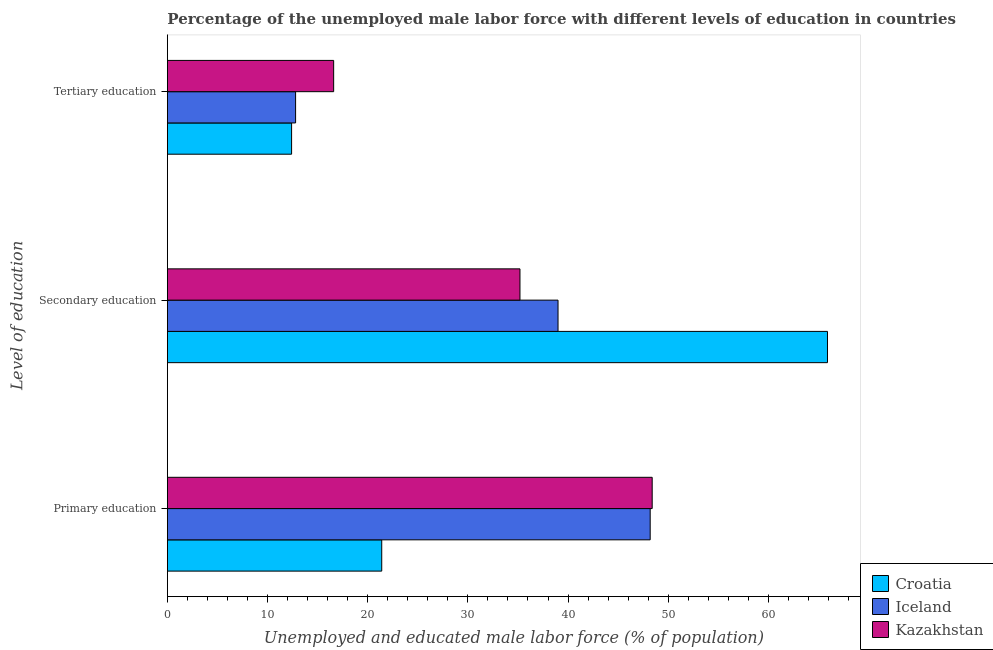How many different coloured bars are there?
Offer a terse response. 3. How many bars are there on the 2nd tick from the top?
Your response must be concise. 3. What is the label of the 2nd group of bars from the top?
Your answer should be compact. Secondary education. What is the percentage of male labor force who received secondary education in Croatia?
Provide a succinct answer. 65.9. Across all countries, what is the maximum percentage of male labor force who received tertiary education?
Make the answer very short. 16.6. Across all countries, what is the minimum percentage of male labor force who received secondary education?
Give a very brief answer. 35.2. In which country was the percentage of male labor force who received primary education maximum?
Your response must be concise. Kazakhstan. In which country was the percentage of male labor force who received tertiary education minimum?
Keep it short and to the point. Croatia. What is the total percentage of male labor force who received secondary education in the graph?
Offer a terse response. 140.1. What is the difference between the percentage of male labor force who received secondary education in Croatia and that in Kazakhstan?
Your response must be concise. 30.7. What is the difference between the percentage of male labor force who received primary education in Croatia and the percentage of male labor force who received tertiary education in Kazakhstan?
Keep it short and to the point. 4.8. What is the average percentage of male labor force who received tertiary education per country?
Provide a succinct answer. 13.93. What is the difference between the percentage of male labor force who received secondary education and percentage of male labor force who received tertiary education in Iceland?
Give a very brief answer. 26.2. What is the ratio of the percentage of male labor force who received tertiary education in Iceland to that in Croatia?
Offer a terse response. 1.03. Is the percentage of male labor force who received primary education in Croatia less than that in Kazakhstan?
Your answer should be compact. Yes. Is the difference between the percentage of male labor force who received secondary education in Croatia and Iceland greater than the difference between the percentage of male labor force who received tertiary education in Croatia and Iceland?
Your response must be concise. Yes. What is the difference between the highest and the second highest percentage of male labor force who received secondary education?
Ensure brevity in your answer.  26.9. What is the difference between the highest and the lowest percentage of male labor force who received primary education?
Your answer should be very brief. 27. In how many countries, is the percentage of male labor force who received primary education greater than the average percentage of male labor force who received primary education taken over all countries?
Ensure brevity in your answer.  2. Is the sum of the percentage of male labor force who received primary education in Iceland and Kazakhstan greater than the maximum percentage of male labor force who received tertiary education across all countries?
Make the answer very short. Yes. What does the 2nd bar from the top in Tertiary education represents?
Offer a very short reply. Iceland. What does the 3rd bar from the bottom in Tertiary education represents?
Give a very brief answer. Kazakhstan. Is it the case that in every country, the sum of the percentage of male labor force who received primary education and percentage of male labor force who received secondary education is greater than the percentage of male labor force who received tertiary education?
Give a very brief answer. Yes. How many bars are there?
Keep it short and to the point. 9. What is the difference between two consecutive major ticks on the X-axis?
Keep it short and to the point. 10. Does the graph contain grids?
Provide a short and direct response. No. How many legend labels are there?
Provide a succinct answer. 3. How are the legend labels stacked?
Provide a short and direct response. Vertical. What is the title of the graph?
Make the answer very short. Percentage of the unemployed male labor force with different levels of education in countries. Does "Sub-Saharan Africa (all income levels)" appear as one of the legend labels in the graph?
Keep it short and to the point. No. What is the label or title of the X-axis?
Ensure brevity in your answer.  Unemployed and educated male labor force (% of population). What is the label or title of the Y-axis?
Your response must be concise. Level of education. What is the Unemployed and educated male labor force (% of population) in Croatia in Primary education?
Provide a short and direct response. 21.4. What is the Unemployed and educated male labor force (% of population) of Iceland in Primary education?
Your response must be concise. 48.2. What is the Unemployed and educated male labor force (% of population) of Kazakhstan in Primary education?
Your response must be concise. 48.4. What is the Unemployed and educated male labor force (% of population) in Croatia in Secondary education?
Make the answer very short. 65.9. What is the Unemployed and educated male labor force (% of population) of Kazakhstan in Secondary education?
Offer a very short reply. 35.2. What is the Unemployed and educated male labor force (% of population) in Croatia in Tertiary education?
Provide a short and direct response. 12.4. What is the Unemployed and educated male labor force (% of population) in Iceland in Tertiary education?
Keep it short and to the point. 12.8. What is the Unemployed and educated male labor force (% of population) in Kazakhstan in Tertiary education?
Keep it short and to the point. 16.6. Across all Level of education, what is the maximum Unemployed and educated male labor force (% of population) in Croatia?
Give a very brief answer. 65.9. Across all Level of education, what is the maximum Unemployed and educated male labor force (% of population) of Iceland?
Your answer should be very brief. 48.2. Across all Level of education, what is the maximum Unemployed and educated male labor force (% of population) of Kazakhstan?
Provide a succinct answer. 48.4. Across all Level of education, what is the minimum Unemployed and educated male labor force (% of population) of Croatia?
Keep it short and to the point. 12.4. Across all Level of education, what is the minimum Unemployed and educated male labor force (% of population) of Iceland?
Make the answer very short. 12.8. Across all Level of education, what is the minimum Unemployed and educated male labor force (% of population) in Kazakhstan?
Offer a very short reply. 16.6. What is the total Unemployed and educated male labor force (% of population) of Croatia in the graph?
Keep it short and to the point. 99.7. What is the total Unemployed and educated male labor force (% of population) in Iceland in the graph?
Offer a terse response. 100. What is the total Unemployed and educated male labor force (% of population) of Kazakhstan in the graph?
Ensure brevity in your answer.  100.2. What is the difference between the Unemployed and educated male labor force (% of population) in Croatia in Primary education and that in Secondary education?
Make the answer very short. -44.5. What is the difference between the Unemployed and educated male labor force (% of population) in Iceland in Primary education and that in Secondary education?
Offer a very short reply. 9.2. What is the difference between the Unemployed and educated male labor force (% of population) in Croatia in Primary education and that in Tertiary education?
Your answer should be compact. 9. What is the difference between the Unemployed and educated male labor force (% of population) of Iceland in Primary education and that in Tertiary education?
Offer a terse response. 35.4. What is the difference between the Unemployed and educated male labor force (% of population) in Kazakhstan in Primary education and that in Tertiary education?
Your answer should be compact. 31.8. What is the difference between the Unemployed and educated male labor force (% of population) in Croatia in Secondary education and that in Tertiary education?
Provide a short and direct response. 53.5. What is the difference between the Unemployed and educated male labor force (% of population) in Iceland in Secondary education and that in Tertiary education?
Offer a very short reply. 26.2. What is the difference between the Unemployed and educated male labor force (% of population) of Kazakhstan in Secondary education and that in Tertiary education?
Keep it short and to the point. 18.6. What is the difference between the Unemployed and educated male labor force (% of population) of Croatia in Primary education and the Unemployed and educated male labor force (% of population) of Iceland in Secondary education?
Your response must be concise. -17.6. What is the difference between the Unemployed and educated male labor force (% of population) of Iceland in Primary education and the Unemployed and educated male labor force (% of population) of Kazakhstan in Secondary education?
Your answer should be compact. 13. What is the difference between the Unemployed and educated male labor force (% of population) in Croatia in Primary education and the Unemployed and educated male labor force (% of population) in Kazakhstan in Tertiary education?
Keep it short and to the point. 4.8. What is the difference between the Unemployed and educated male labor force (% of population) of Iceland in Primary education and the Unemployed and educated male labor force (% of population) of Kazakhstan in Tertiary education?
Provide a short and direct response. 31.6. What is the difference between the Unemployed and educated male labor force (% of population) in Croatia in Secondary education and the Unemployed and educated male labor force (% of population) in Iceland in Tertiary education?
Offer a terse response. 53.1. What is the difference between the Unemployed and educated male labor force (% of population) in Croatia in Secondary education and the Unemployed and educated male labor force (% of population) in Kazakhstan in Tertiary education?
Your response must be concise. 49.3. What is the difference between the Unemployed and educated male labor force (% of population) in Iceland in Secondary education and the Unemployed and educated male labor force (% of population) in Kazakhstan in Tertiary education?
Keep it short and to the point. 22.4. What is the average Unemployed and educated male labor force (% of population) of Croatia per Level of education?
Offer a very short reply. 33.23. What is the average Unemployed and educated male labor force (% of population) in Iceland per Level of education?
Offer a terse response. 33.33. What is the average Unemployed and educated male labor force (% of population) of Kazakhstan per Level of education?
Offer a very short reply. 33.4. What is the difference between the Unemployed and educated male labor force (% of population) in Croatia and Unemployed and educated male labor force (% of population) in Iceland in Primary education?
Make the answer very short. -26.8. What is the difference between the Unemployed and educated male labor force (% of population) of Croatia and Unemployed and educated male labor force (% of population) of Kazakhstan in Primary education?
Your answer should be compact. -27. What is the difference between the Unemployed and educated male labor force (% of population) of Iceland and Unemployed and educated male labor force (% of population) of Kazakhstan in Primary education?
Make the answer very short. -0.2. What is the difference between the Unemployed and educated male labor force (% of population) in Croatia and Unemployed and educated male labor force (% of population) in Iceland in Secondary education?
Offer a very short reply. 26.9. What is the difference between the Unemployed and educated male labor force (% of population) in Croatia and Unemployed and educated male labor force (% of population) in Kazakhstan in Secondary education?
Offer a terse response. 30.7. What is the difference between the Unemployed and educated male labor force (% of population) of Iceland and Unemployed and educated male labor force (% of population) of Kazakhstan in Secondary education?
Provide a short and direct response. 3.8. What is the difference between the Unemployed and educated male labor force (% of population) in Iceland and Unemployed and educated male labor force (% of population) in Kazakhstan in Tertiary education?
Keep it short and to the point. -3.8. What is the ratio of the Unemployed and educated male labor force (% of population) of Croatia in Primary education to that in Secondary education?
Provide a short and direct response. 0.32. What is the ratio of the Unemployed and educated male labor force (% of population) of Iceland in Primary education to that in Secondary education?
Offer a terse response. 1.24. What is the ratio of the Unemployed and educated male labor force (% of population) of Kazakhstan in Primary education to that in Secondary education?
Provide a short and direct response. 1.38. What is the ratio of the Unemployed and educated male labor force (% of population) in Croatia in Primary education to that in Tertiary education?
Provide a short and direct response. 1.73. What is the ratio of the Unemployed and educated male labor force (% of population) in Iceland in Primary education to that in Tertiary education?
Provide a succinct answer. 3.77. What is the ratio of the Unemployed and educated male labor force (% of population) of Kazakhstan in Primary education to that in Tertiary education?
Your answer should be very brief. 2.92. What is the ratio of the Unemployed and educated male labor force (% of population) in Croatia in Secondary education to that in Tertiary education?
Offer a terse response. 5.31. What is the ratio of the Unemployed and educated male labor force (% of population) of Iceland in Secondary education to that in Tertiary education?
Give a very brief answer. 3.05. What is the ratio of the Unemployed and educated male labor force (% of population) of Kazakhstan in Secondary education to that in Tertiary education?
Offer a very short reply. 2.12. What is the difference between the highest and the second highest Unemployed and educated male labor force (% of population) in Croatia?
Your answer should be compact. 44.5. What is the difference between the highest and the second highest Unemployed and educated male labor force (% of population) in Iceland?
Ensure brevity in your answer.  9.2. What is the difference between the highest and the lowest Unemployed and educated male labor force (% of population) in Croatia?
Your answer should be compact. 53.5. What is the difference between the highest and the lowest Unemployed and educated male labor force (% of population) in Iceland?
Your answer should be very brief. 35.4. What is the difference between the highest and the lowest Unemployed and educated male labor force (% of population) of Kazakhstan?
Provide a short and direct response. 31.8. 